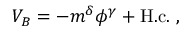<formula> <loc_0><loc_0><loc_500><loc_500>V _ { B } = - m ^ { \delta } \phi ^ { \gamma } + H . c . \ ,</formula> 